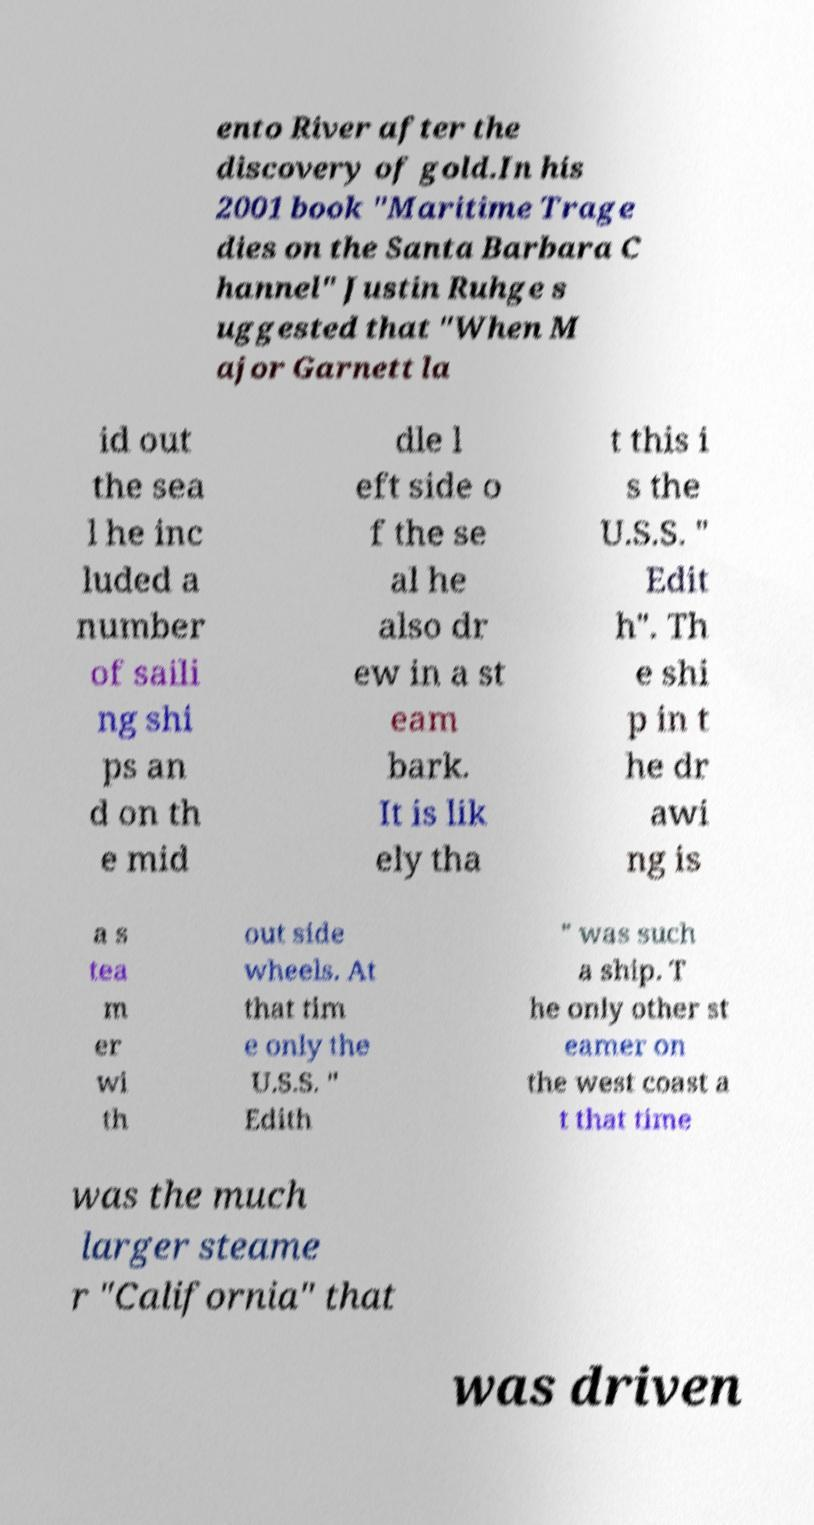Can you accurately transcribe the text from the provided image for me? ento River after the discovery of gold.In his 2001 book "Maritime Trage dies on the Santa Barbara C hannel" Justin Ruhge s uggested that "When M ajor Garnett la id out the sea l he inc luded a number of saili ng shi ps an d on th e mid dle l eft side o f the se al he also dr ew in a st eam bark. It is lik ely tha t this i s the U.S.S. " Edit h". Th e shi p in t he dr awi ng is a s tea m er wi th out side wheels. At that tim e only the U.S.S. " Edith " was such a ship. T he only other st eamer on the west coast a t that time was the much larger steame r "California" that was driven 